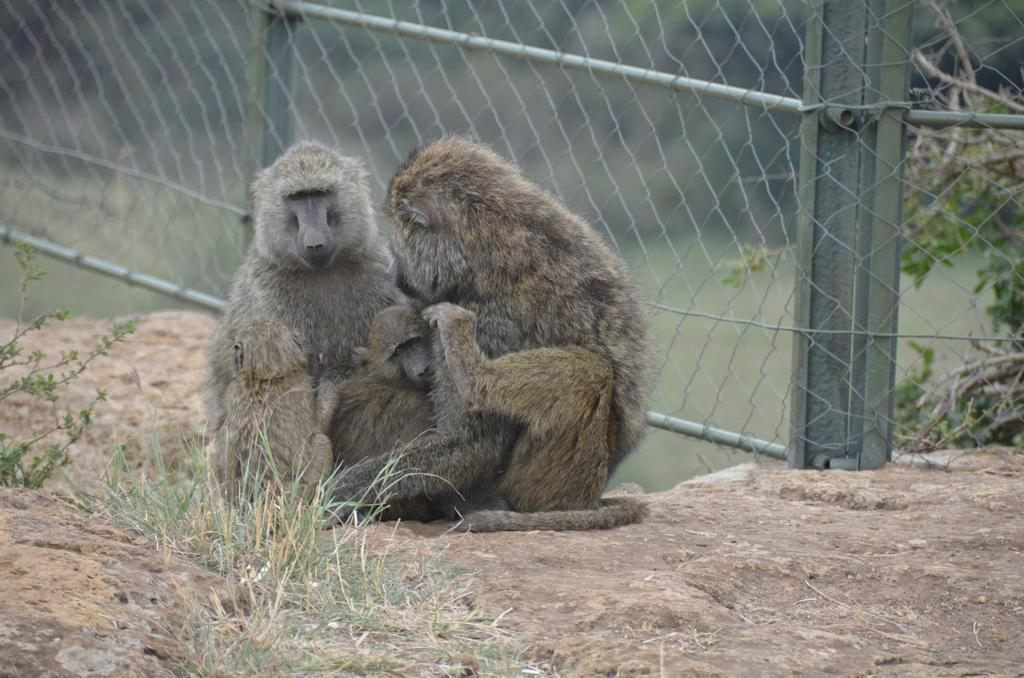How many monkeys are in the image? There are three monkeys on the ground in the image. What type of terrain is visible in the image? There is grass visible in the image. What other natural elements can be seen in the image? There are plants in the image. What type of barrier is present in the image? There is fencing in the image. Can you describe the background of the image? The background of the image is blurred. What type of tree is the monkey climbing in the image? There is no tree present in the image; the monkeys are on the ground. 